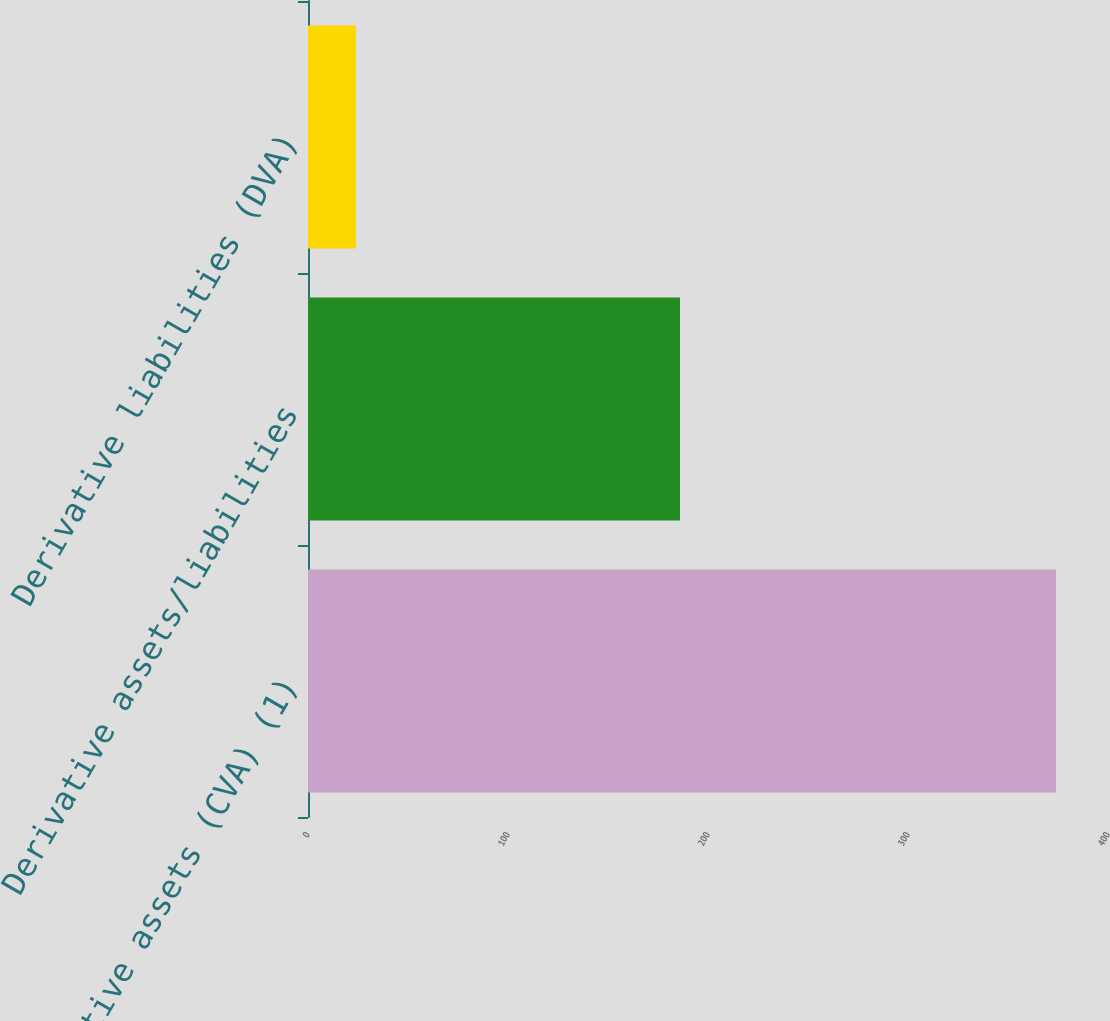Convert chart to OTSL. <chart><loc_0><loc_0><loc_500><loc_500><bar_chart><fcel>Derivative assets (CVA) (1)<fcel>Derivative assets/liabilities<fcel>Derivative liabilities (DVA)<nl><fcel>374<fcel>186<fcel>24<nl></chart> 